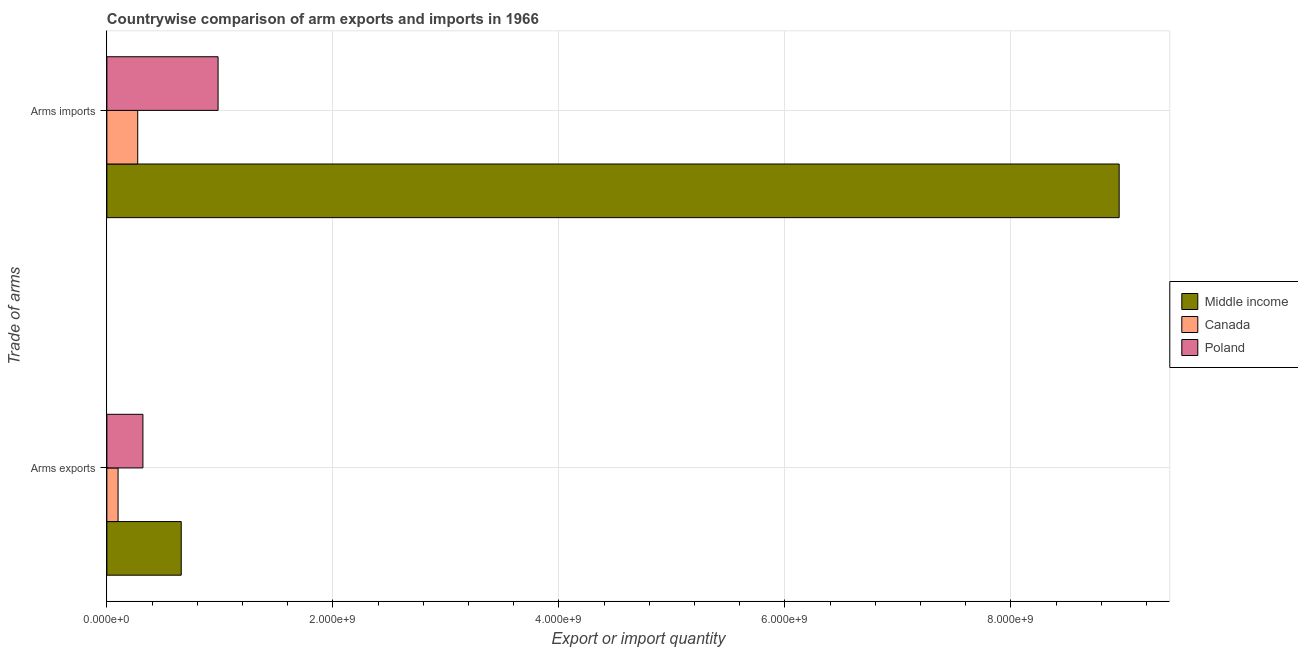How many different coloured bars are there?
Offer a very short reply. 3. How many groups of bars are there?
Make the answer very short. 2. Are the number of bars per tick equal to the number of legend labels?
Keep it short and to the point. Yes. How many bars are there on the 1st tick from the bottom?
Provide a succinct answer. 3. What is the label of the 2nd group of bars from the top?
Make the answer very short. Arms exports. What is the arms exports in Middle income?
Offer a very short reply. 6.58e+08. Across all countries, what is the maximum arms imports?
Offer a very short reply. 8.96e+09. Across all countries, what is the minimum arms exports?
Offer a terse response. 9.90e+07. In which country was the arms imports maximum?
Give a very brief answer. Middle income. In which country was the arms exports minimum?
Make the answer very short. Canada. What is the total arms imports in the graph?
Offer a very short reply. 1.02e+1. What is the difference between the arms exports in Poland and that in Middle income?
Ensure brevity in your answer.  -3.39e+08. What is the difference between the arms imports in Canada and the arms exports in Middle income?
Ensure brevity in your answer.  -3.85e+08. What is the average arms imports per country?
Keep it short and to the point. 3.40e+09. What is the difference between the arms exports and arms imports in Canada?
Make the answer very short. -1.74e+08. In how many countries, is the arms exports greater than 1200000000 ?
Make the answer very short. 0. What is the ratio of the arms exports in Middle income to that in Canada?
Your response must be concise. 6.65. Is the arms exports in Poland less than that in Middle income?
Offer a terse response. Yes. In how many countries, is the arms imports greater than the average arms imports taken over all countries?
Your answer should be very brief. 1. What does the 3rd bar from the bottom in Arms exports represents?
Give a very brief answer. Poland. What is the difference between two consecutive major ticks on the X-axis?
Your answer should be compact. 2.00e+09. Are the values on the major ticks of X-axis written in scientific E-notation?
Give a very brief answer. Yes. Does the graph contain any zero values?
Ensure brevity in your answer.  No. Does the graph contain grids?
Offer a very short reply. Yes. Where does the legend appear in the graph?
Keep it short and to the point. Center right. How are the legend labels stacked?
Your answer should be compact. Vertical. What is the title of the graph?
Give a very brief answer. Countrywise comparison of arm exports and imports in 1966. Does "Philippines" appear as one of the legend labels in the graph?
Your response must be concise. No. What is the label or title of the X-axis?
Provide a succinct answer. Export or import quantity. What is the label or title of the Y-axis?
Offer a terse response. Trade of arms. What is the Export or import quantity of Middle income in Arms exports?
Make the answer very short. 6.58e+08. What is the Export or import quantity of Canada in Arms exports?
Your answer should be very brief. 9.90e+07. What is the Export or import quantity of Poland in Arms exports?
Provide a short and direct response. 3.19e+08. What is the Export or import quantity of Middle income in Arms imports?
Keep it short and to the point. 8.96e+09. What is the Export or import quantity in Canada in Arms imports?
Your response must be concise. 2.73e+08. What is the Export or import quantity of Poland in Arms imports?
Ensure brevity in your answer.  9.84e+08. Across all Trade of arms, what is the maximum Export or import quantity in Middle income?
Ensure brevity in your answer.  8.96e+09. Across all Trade of arms, what is the maximum Export or import quantity of Canada?
Offer a very short reply. 2.73e+08. Across all Trade of arms, what is the maximum Export or import quantity of Poland?
Your response must be concise. 9.84e+08. Across all Trade of arms, what is the minimum Export or import quantity in Middle income?
Make the answer very short. 6.58e+08. Across all Trade of arms, what is the minimum Export or import quantity of Canada?
Make the answer very short. 9.90e+07. Across all Trade of arms, what is the minimum Export or import quantity in Poland?
Your answer should be very brief. 3.19e+08. What is the total Export or import quantity of Middle income in the graph?
Give a very brief answer. 9.62e+09. What is the total Export or import quantity in Canada in the graph?
Provide a succinct answer. 3.72e+08. What is the total Export or import quantity of Poland in the graph?
Give a very brief answer. 1.30e+09. What is the difference between the Export or import quantity in Middle income in Arms exports and that in Arms imports?
Offer a terse response. -8.30e+09. What is the difference between the Export or import quantity of Canada in Arms exports and that in Arms imports?
Your answer should be very brief. -1.74e+08. What is the difference between the Export or import quantity in Poland in Arms exports and that in Arms imports?
Your answer should be very brief. -6.65e+08. What is the difference between the Export or import quantity in Middle income in Arms exports and the Export or import quantity in Canada in Arms imports?
Provide a short and direct response. 3.85e+08. What is the difference between the Export or import quantity in Middle income in Arms exports and the Export or import quantity in Poland in Arms imports?
Provide a succinct answer. -3.26e+08. What is the difference between the Export or import quantity of Canada in Arms exports and the Export or import quantity of Poland in Arms imports?
Provide a short and direct response. -8.85e+08. What is the average Export or import quantity in Middle income per Trade of arms?
Your answer should be compact. 4.81e+09. What is the average Export or import quantity of Canada per Trade of arms?
Your response must be concise. 1.86e+08. What is the average Export or import quantity in Poland per Trade of arms?
Your answer should be compact. 6.52e+08. What is the difference between the Export or import quantity of Middle income and Export or import quantity of Canada in Arms exports?
Offer a terse response. 5.59e+08. What is the difference between the Export or import quantity in Middle income and Export or import quantity in Poland in Arms exports?
Give a very brief answer. 3.39e+08. What is the difference between the Export or import quantity of Canada and Export or import quantity of Poland in Arms exports?
Make the answer very short. -2.20e+08. What is the difference between the Export or import quantity in Middle income and Export or import quantity in Canada in Arms imports?
Your answer should be very brief. 8.68e+09. What is the difference between the Export or import quantity in Middle income and Export or import quantity in Poland in Arms imports?
Offer a very short reply. 7.97e+09. What is the difference between the Export or import quantity of Canada and Export or import quantity of Poland in Arms imports?
Provide a succinct answer. -7.11e+08. What is the ratio of the Export or import quantity in Middle income in Arms exports to that in Arms imports?
Ensure brevity in your answer.  0.07. What is the ratio of the Export or import quantity of Canada in Arms exports to that in Arms imports?
Your answer should be compact. 0.36. What is the ratio of the Export or import quantity of Poland in Arms exports to that in Arms imports?
Your answer should be compact. 0.32. What is the difference between the highest and the second highest Export or import quantity of Middle income?
Your answer should be compact. 8.30e+09. What is the difference between the highest and the second highest Export or import quantity of Canada?
Your answer should be compact. 1.74e+08. What is the difference between the highest and the second highest Export or import quantity in Poland?
Your response must be concise. 6.65e+08. What is the difference between the highest and the lowest Export or import quantity in Middle income?
Your response must be concise. 8.30e+09. What is the difference between the highest and the lowest Export or import quantity of Canada?
Provide a short and direct response. 1.74e+08. What is the difference between the highest and the lowest Export or import quantity in Poland?
Make the answer very short. 6.65e+08. 